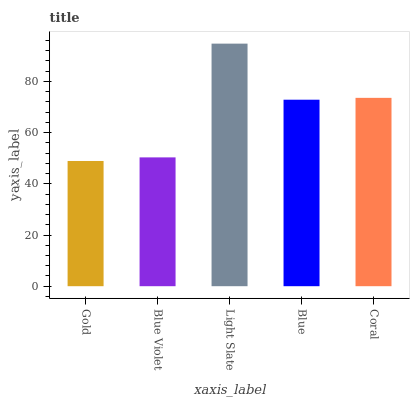Is Gold the minimum?
Answer yes or no. Yes. Is Light Slate the maximum?
Answer yes or no. Yes. Is Blue Violet the minimum?
Answer yes or no. No. Is Blue Violet the maximum?
Answer yes or no. No. Is Blue Violet greater than Gold?
Answer yes or no. Yes. Is Gold less than Blue Violet?
Answer yes or no. Yes. Is Gold greater than Blue Violet?
Answer yes or no. No. Is Blue Violet less than Gold?
Answer yes or no. No. Is Blue the high median?
Answer yes or no. Yes. Is Blue the low median?
Answer yes or no. Yes. Is Light Slate the high median?
Answer yes or no. No. Is Light Slate the low median?
Answer yes or no. No. 